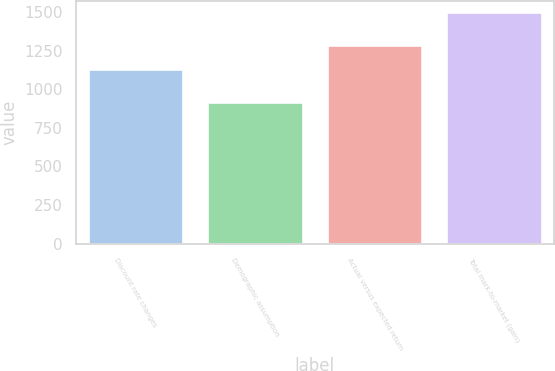<chart> <loc_0><loc_0><loc_500><loc_500><bar_chart><fcel>Discount rate changes<fcel>Demographic assumption<fcel>Actual versus expected return<fcel>Total mark-to-market (gain)<nl><fcel>1129<fcel>916<fcel>1285<fcel>1498<nl></chart> 